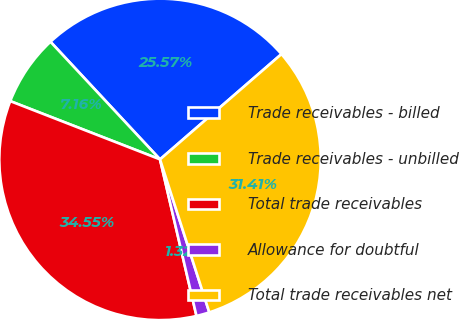Convert chart to OTSL. <chart><loc_0><loc_0><loc_500><loc_500><pie_chart><fcel>Trade receivables - billed<fcel>Trade receivables - unbilled<fcel>Total trade receivables<fcel>Allowance for doubtful<fcel>Total trade receivables net<nl><fcel>25.57%<fcel>7.16%<fcel>34.55%<fcel>1.32%<fcel>31.41%<nl></chart> 